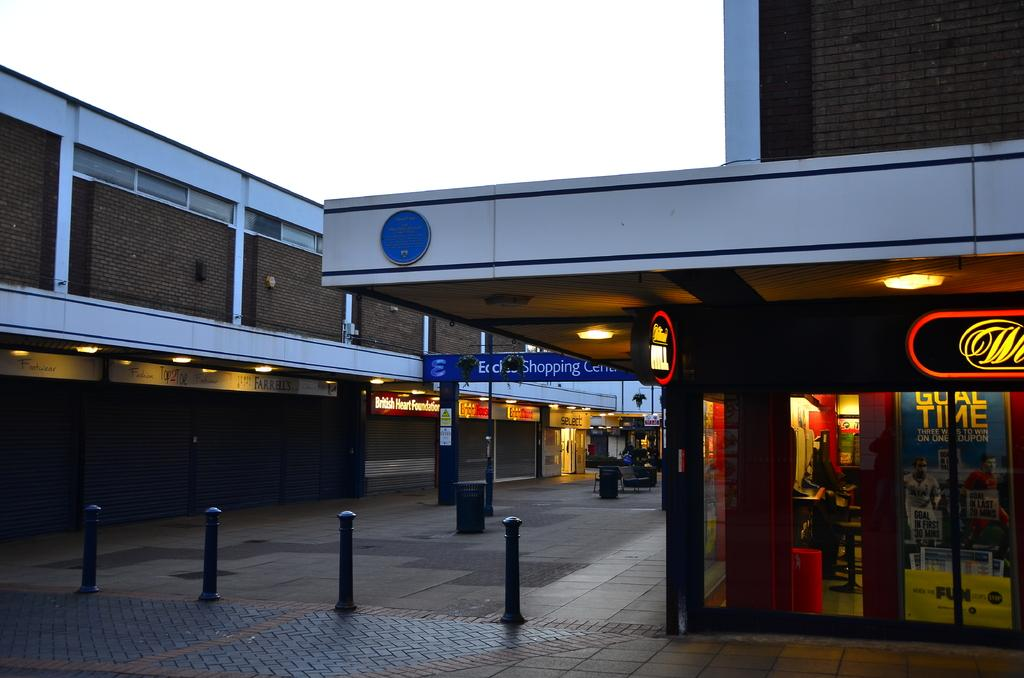<image>
Relay a brief, clear account of the picture shown. A building near a blue sign that says Eccles Shopping Center. 